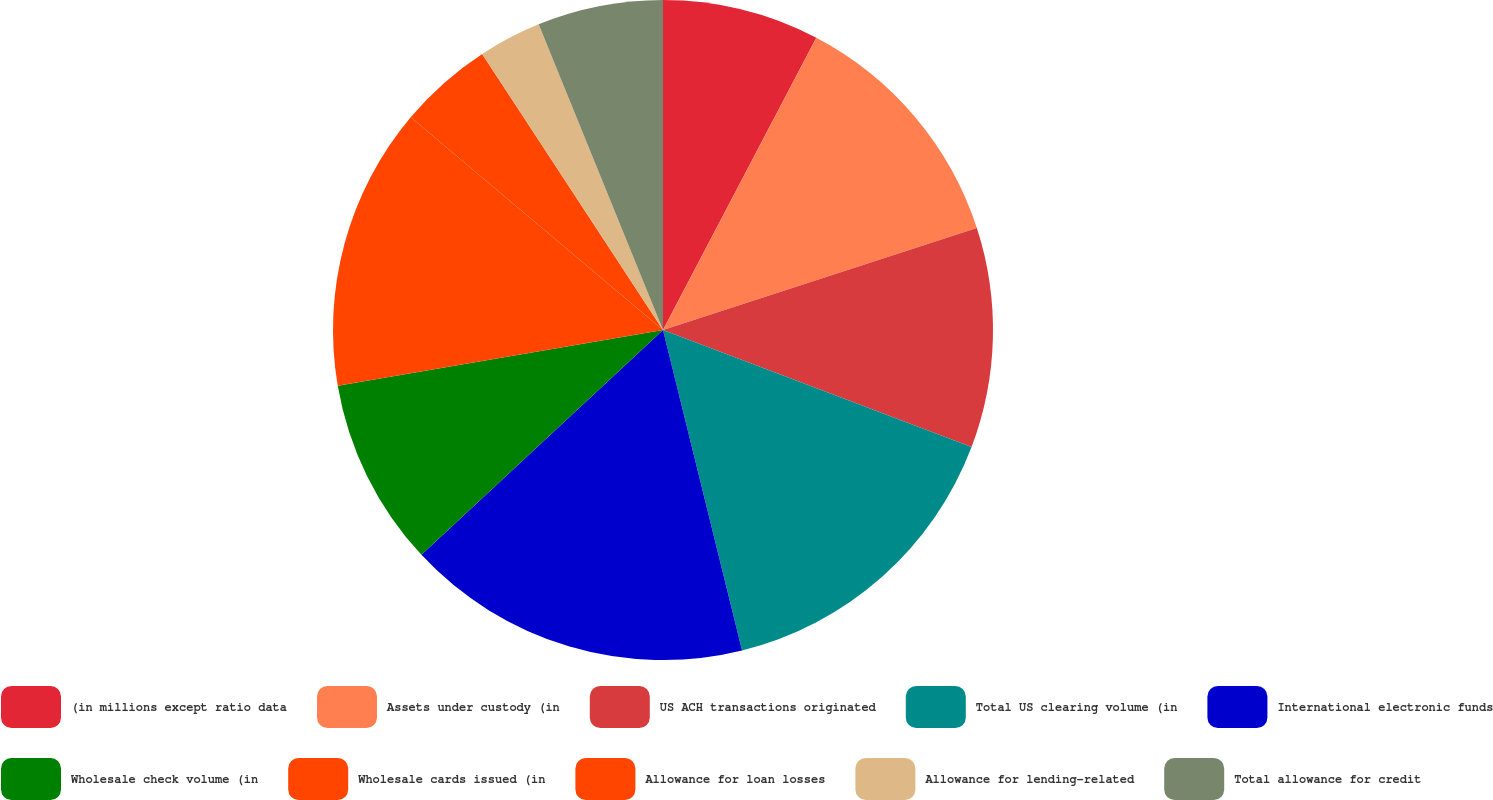Convert chart. <chart><loc_0><loc_0><loc_500><loc_500><pie_chart><fcel>(in millions except ratio data<fcel>Assets under custody (in<fcel>US ACH transactions originated<fcel>Total US clearing volume (in<fcel>International electronic funds<fcel>Wholesale check volume (in<fcel>Wholesale cards issued (in<fcel>Allowance for loan losses<fcel>Allowance for lending-related<fcel>Total allowance for credit<nl><fcel>7.69%<fcel>12.31%<fcel>10.77%<fcel>15.38%<fcel>16.92%<fcel>9.23%<fcel>13.85%<fcel>4.62%<fcel>3.08%<fcel>6.15%<nl></chart> 